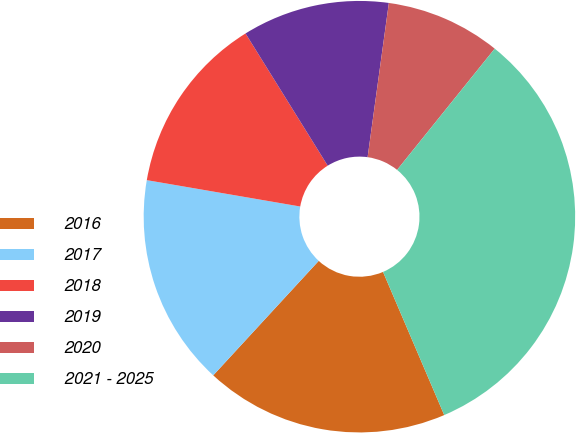Convert chart. <chart><loc_0><loc_0><loc_500><loc_500><pie_chart><fcel>2016<fcel>2017<fcel>2018<fcel>2019<fcel>2020<fcel>2021 - 2025<nl><fcel>18.28%<fcel>15.86%<fcel>13.44%<fcel>11.03%<fcel>8.61%<fcel>32.78%<nl></chart> 